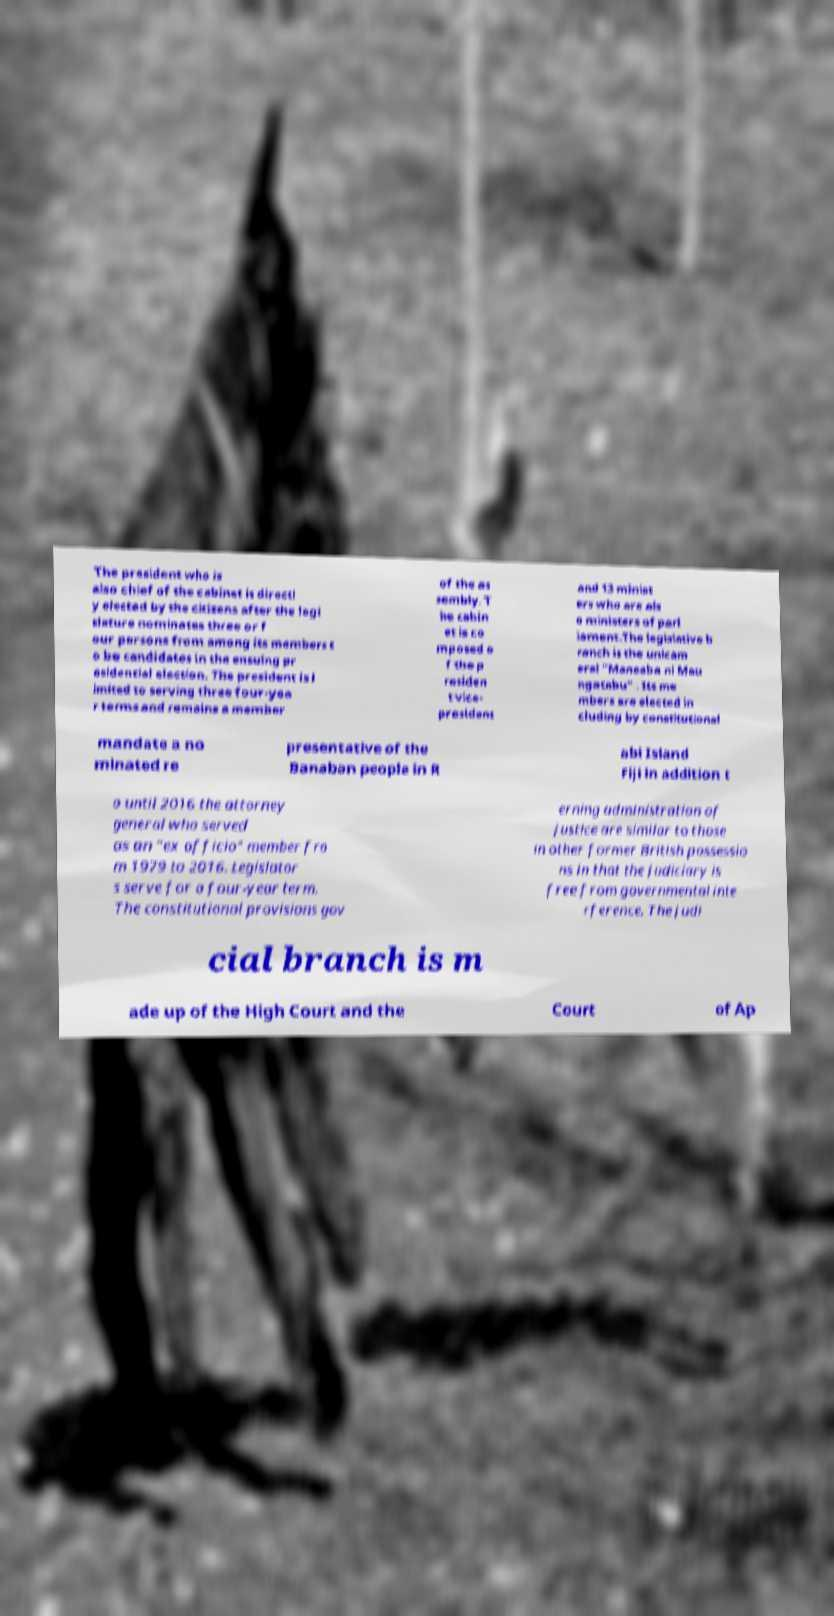There's text embedded in this image that I need extracted. Can you transcribe it verbatim? The president who is also chief of the cabinet is directl y elected by the citizens after the legi slature nominates three or f our persons from among its members t o be candidates in the ensuing pr esidential election. The president is l imited to serving three four-yea r terms and remains a member of the as sembly. T he cabin et is co mposed o f the p residen t vice- president and 13 minist ers who are als o ministers of parl iament.The legislative b ranch is the unicam eral "Maneaba ni Mau ngatabu" . Its me mbers are elected in cluding by constitutional mandate a no minated re presentative of the Banaban people in R abi Island Fiji in addition t o until 2016 the attorney general who served as an "ex officio" member fro m 1979 to 2016. Legislator s serve for a four-year term. The constitutional provisions gov erning administration of justice are similar to those in other former British possessio ns in that the judiciary is free from governmental inte rference. The judi cial branch is m ade up of the High Court and the Court of Ap 